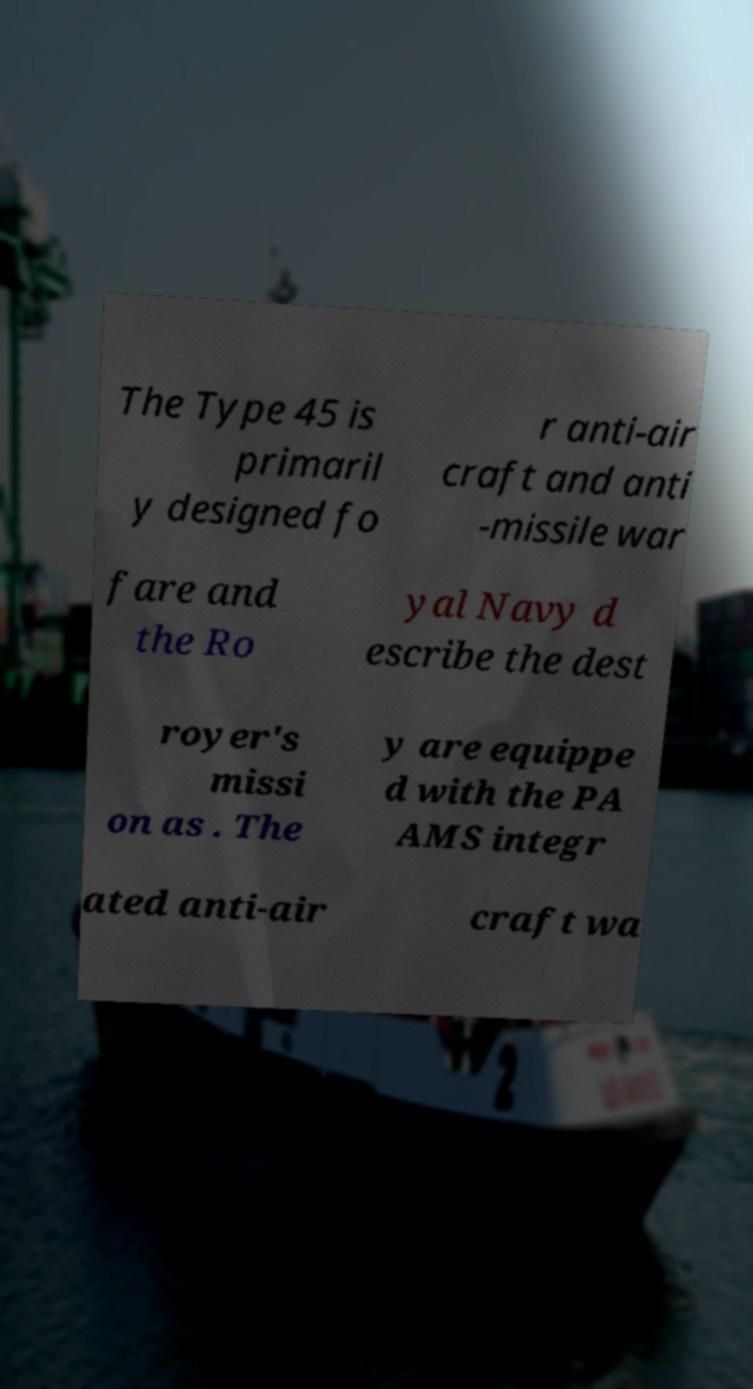Could you extract and type out the text from this image? The Type 45 is primaril y designed fo r anti-air craft and anti -missile war fare and the Ro yal Navy d escribe the dest royer's missi on as . The y are equippe d with the PA AMS integr ated anti-air craft wa 